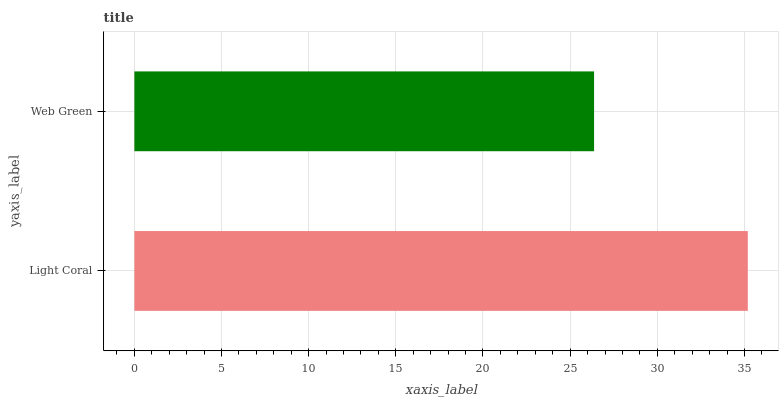Is Web Green the minimum?
Answer yes or no. Yes. Is Light Coral the maximum?
Answer yes or no. Yes. Is Web Green the maximum?
Answer yes or no. No. Is Light Coral greater than Web Green?
Answer yes or no. Yes. Is Web Green less than Light Coral?
Answer yes or no. Yes. Is Web Green greater than Light Coral?
Answer yes or no. No. Is Light Coral less than Web Green?
Answer yes or no. No. Is Light Coral the high median?
Answer yes or no. Yes. Is Web Green the low median?
Answer yes or no. Yes. Is Web Green the high median?
Answer yes or no. No. Is Light Coral the low median?
Answer yes or no. No. 